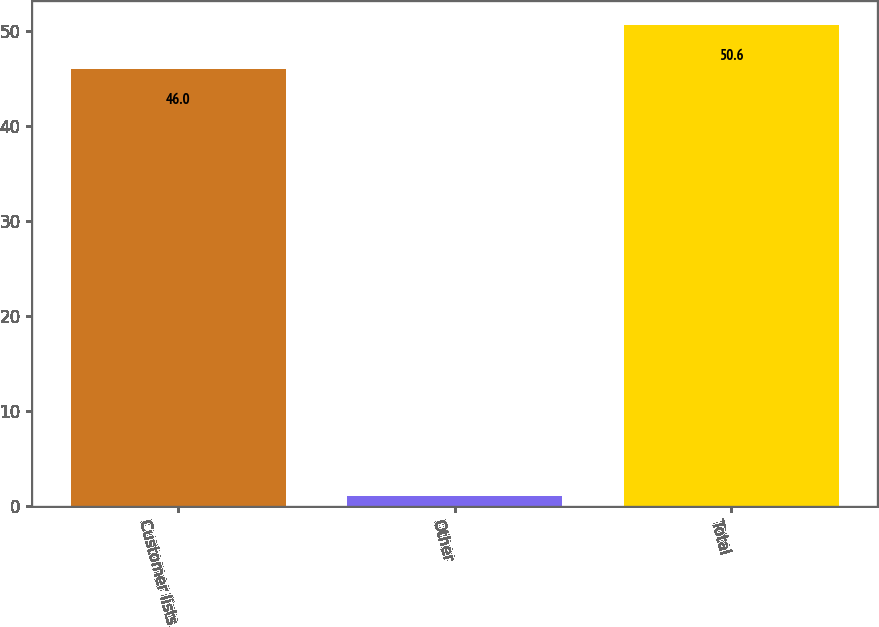Convert chart. <chart><loc_0><loc_0><loc_500><loc_500><bar_chart><fcel>Customer lists<fcel>Other<fcel>Total<nl><fcel>46<fcel>1<fcel>50.6<nl></chart> 